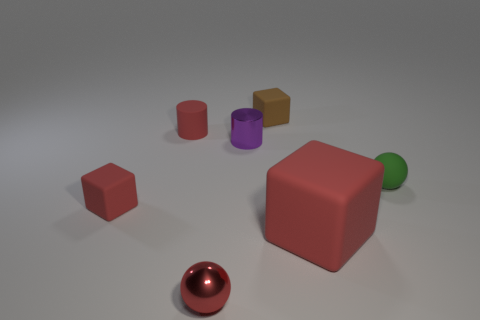Subtract all small rubber cubes. How many cubes are left? 1 Subtract all red cylinders. How many red blocks are left? 2 Add 2 small yellow shiny cubes. How many objects exist? 9 Subtract all balls. How many objects are left? 5 Add 2 tiny purple metallic objects. How many tiny purple metallic objects exist? 3 Subtract 0 cyan cylinders. How many objects are left? 7 Subtract all yellow cubes. Subtract all blue spheres. How many cubes are left? 3 Subtract all tiny red things. Subtract all big red blocks. How many objects are left? 3 Add 2 tiny red things. How many tiny red things are left? 5 